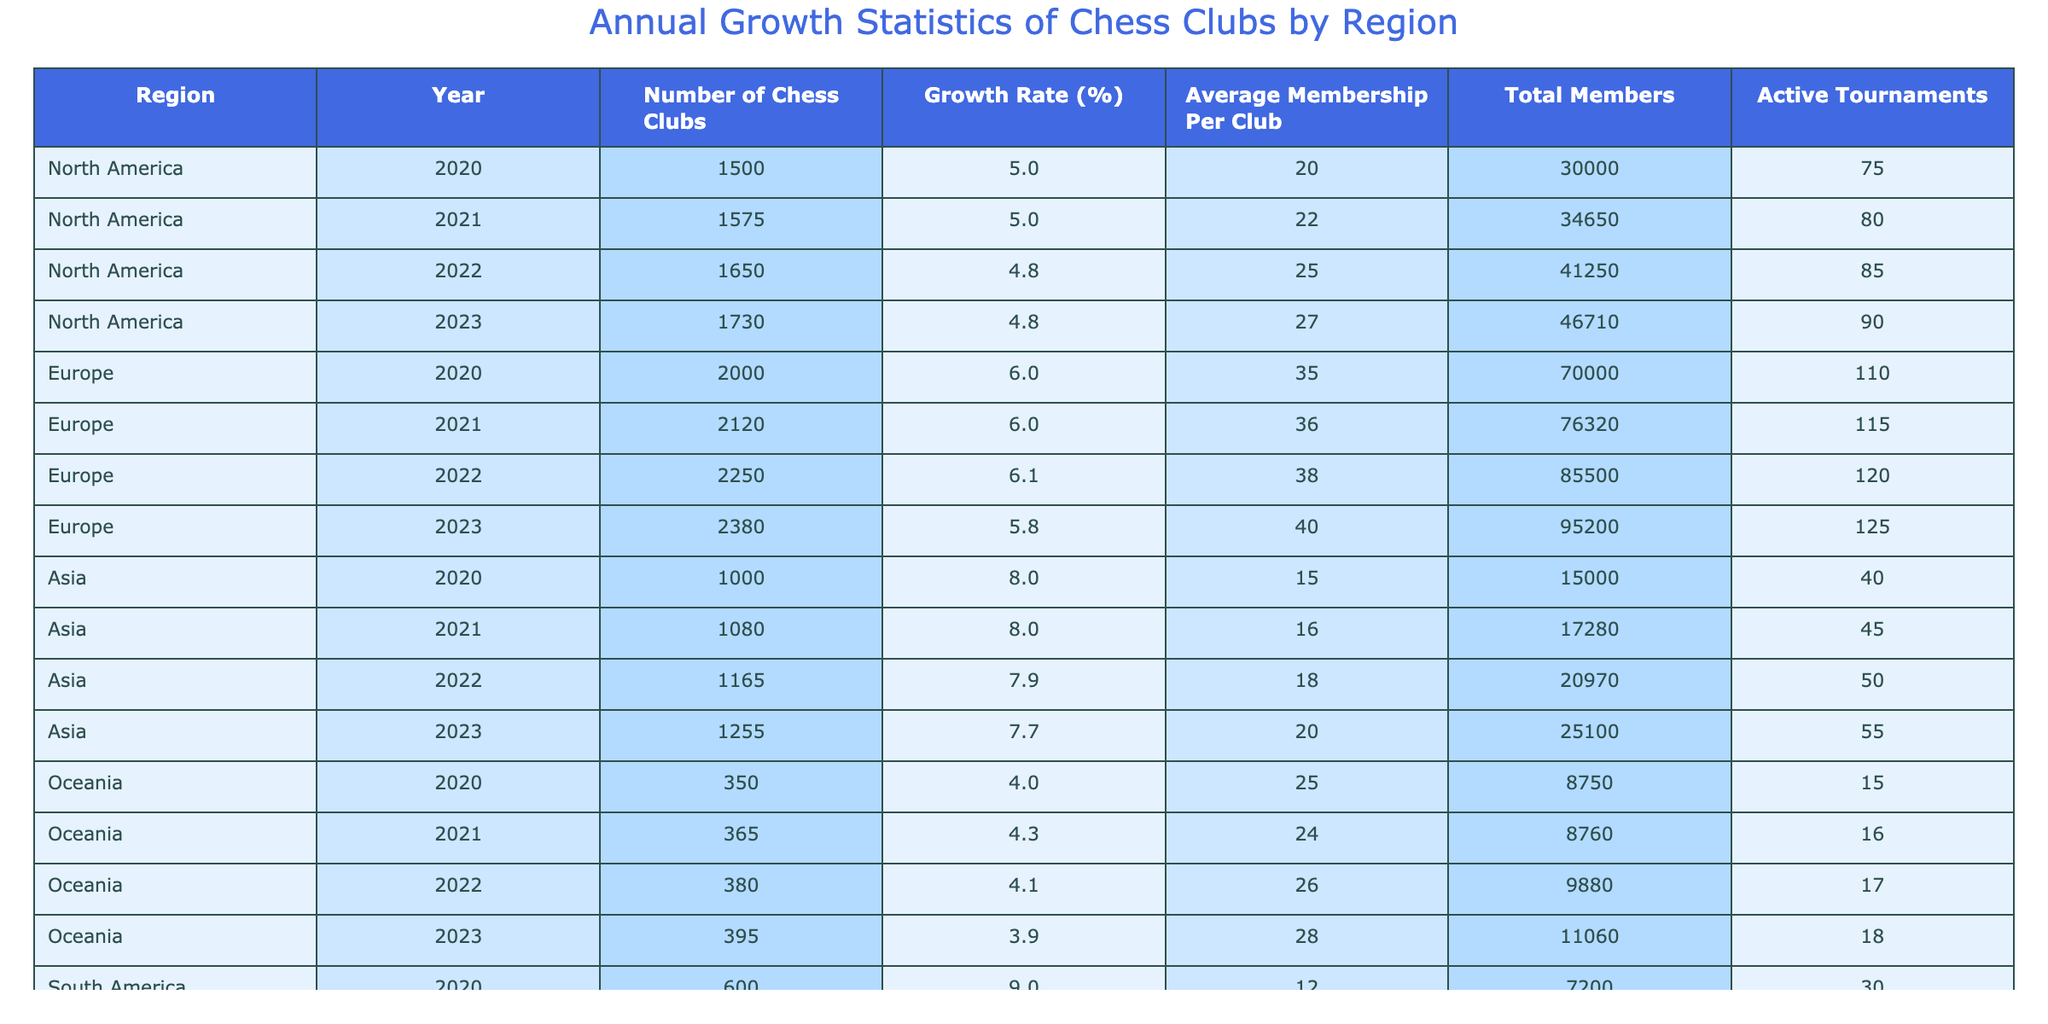What was the growth rate of chess clubs in North America in 2022? From the table, we can directly read the value for growth rate in North America for the year 2022, which is listed as 4.8%.
Answer: 4.8% Which region had the highest average membership per club in 2023? Looking at the average membership per club for each region in 2023, Europe has the highest at 40 members per club.
Answer: Europe What is the total number of members in South America in 2021? By referencing the South America row for the year 2021, the number of total members is listed as 9100.
Answer: 9100 What was the change in the number of chess clubs in Asia from 2020 to 2023? The number of chess clubs in Asia increased from 1000 in 2020 to 1255 in 2023. The change is calculated as 1255 - 1000 = 255.
Answer: 255 Did Africa see a growth rate of over 3% in any year from 2020 to 2023? Checking the growth rates for Africa from 2020 to 2023, the rates are 3.5%, 2.5%, 2.4%, and 2.2%. Only the value for 2020 exceeds 3%.
Answer: Yes What is the average growth rate for chess clubs across all regions in 2022? To find the average growth rate for 2022, sum the growth rates of all regions: 4.8% (North America) + 6.1% (Europe) + 7.9% (Asia) + 4.1% (Oceania) + 7.7% (South America) + 2.4% (Africa) = 33.0%. Then divide by 6 (number of regions), which gives 33.0% / 6 = 5.5%.
Answer: 5.5% Which region had the lowest total members in 2023? Referring to the total members for each region in 2023: North America 46710, Europe 95200, Asia 25100, Oceania 11060, South America 12750, Africa 6020. The lowest is Africa with 6020 total members.
Answer: Africa What is the difference in the number of active tournaments between Europe and South America in 2023? From the table, Europe had 125 active tournaments and South America had 38 in 2023. The difference is calculated as 125 - 38 = 87 tournaments.
Answer: 87 What is the total growth of chess clubs in Oceania between 2020 and 2023? The number of chess clubs in Oceania has increased from 350 in 2020 to 395 in 2023. The total growth is 395 - 350 = 45 chess clubs.
Answer: 45 